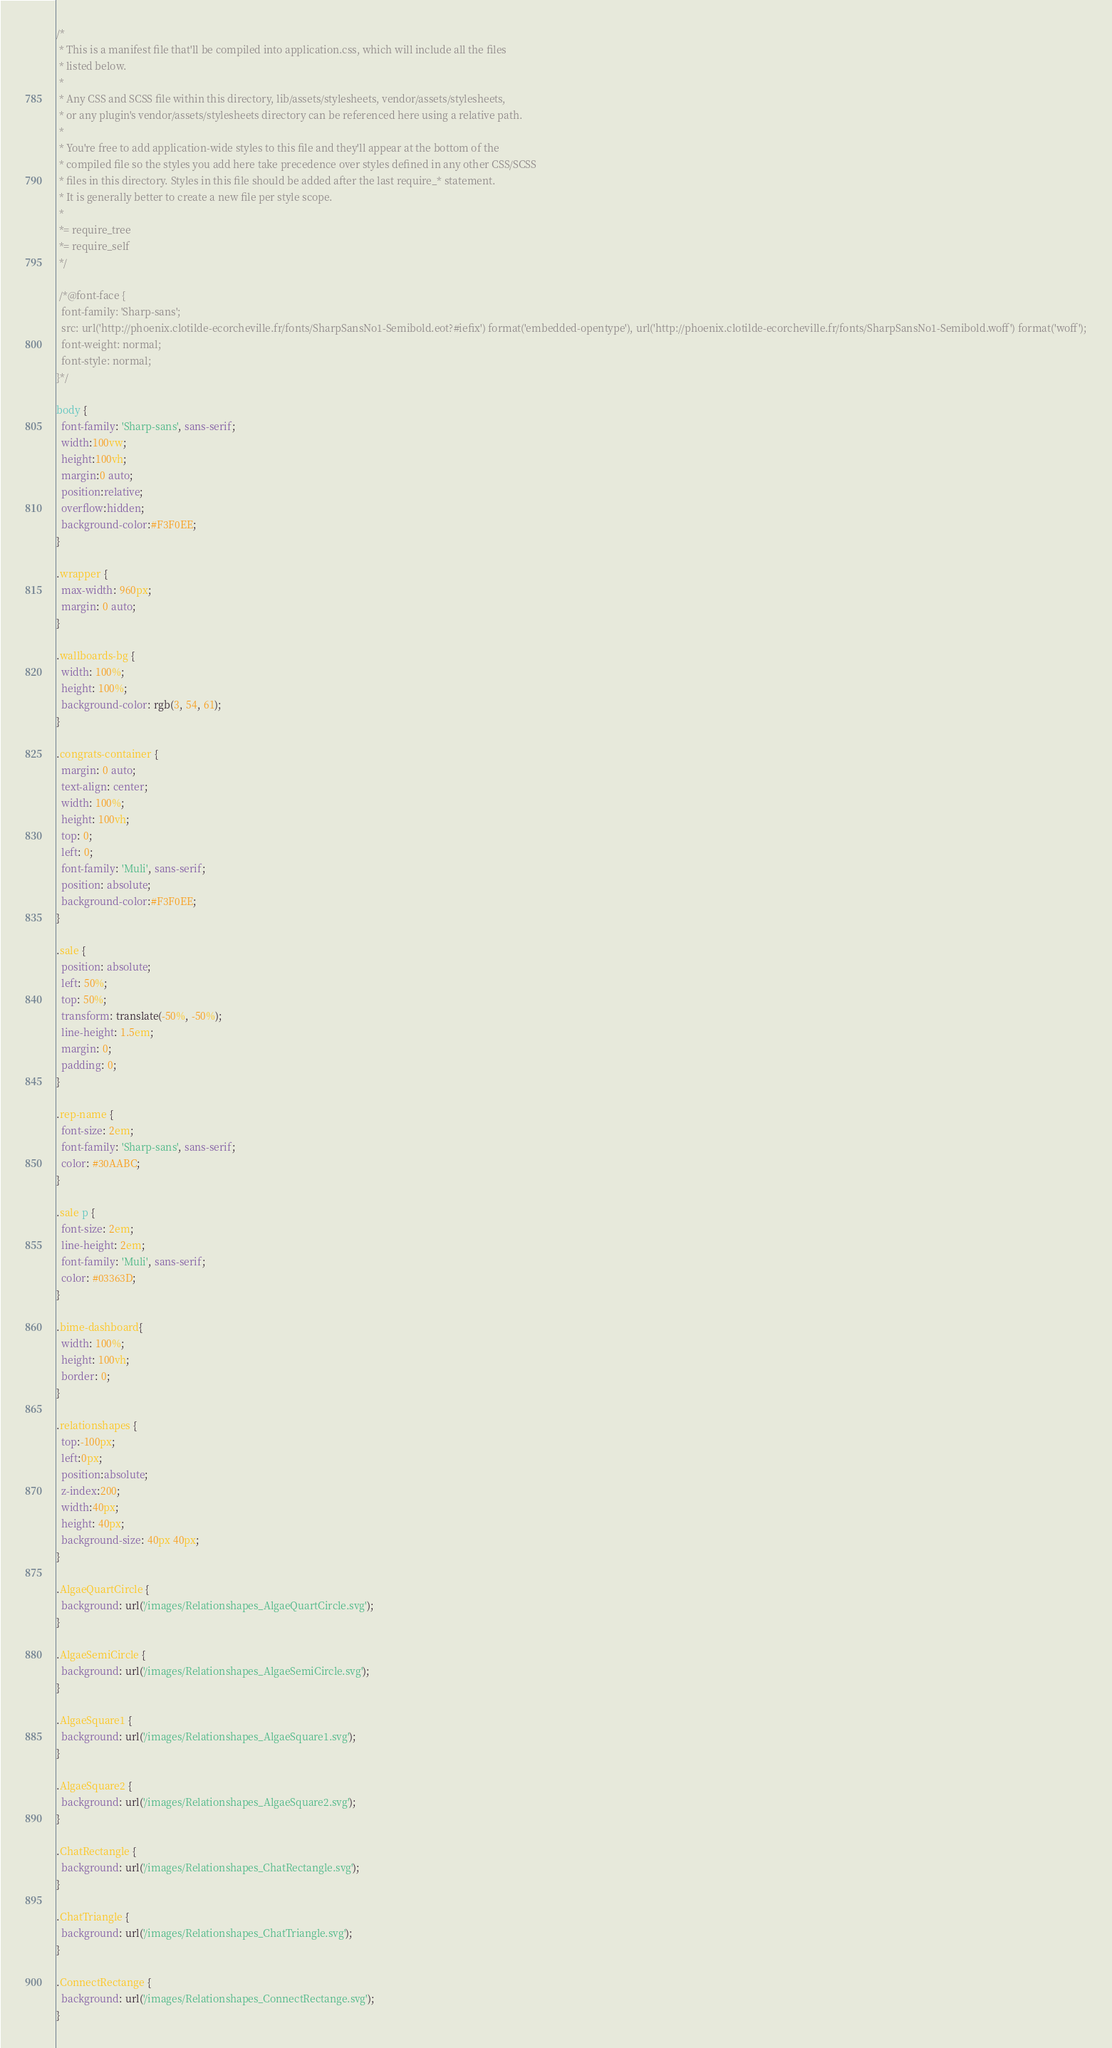<code> <loc_0><loc_0><loc_500><loc_500><_CSS_>/*
 * This is a manifest file that'll be compiled into application.css, which will include all the files
 * listed below.
 *
 * Any CSS and SCSS file within this directory, lib/assets/stylesheets, vendor/assets/stylesheets,
 * or any plugin's vendor/assets/stylesheets directory can be referenced here using a relative path.
 *
 * You're free to add application-wide styles to this file and they'll appear at the bottom of the
 * compiled file so the styles you add here take precedence over styles defined in any other CSS/SCSS
 * files in this directory. Styles in this file should be added after the last require_* statement.
 * It is generally better to create a new file per style scope.
 *
 *= require_tree
 *= require_self
 */

 /*@font-face {
  font-family: 'Sharp-sans';
  src: url('http://phoenix.clotilde-ecorcheville.fr/fonts/SharpSansNo1-Semibold.eot?#iefix') format('embedded-opentype'), url('http://phoenix.clotilde-ecorcheville.fr/fonts/SharpSansNo1-Semibold.woff') format('woff');
  font-weight: normal;
  font-style: normal;
}*/

body {
  font-family: 'Sharp-sans', sans-serif;
  width:100vw;
  height:100vh;
  margin:0 auto;
  position:relative;
  overflow:hidden;
  background-color:#F3F0EE;
}

.wrapper {
  max-width: 960px;
  margin: 0 auto;
}

.wallboards-bg {
  width: 100%;
  height: 100%;
  background-color: rgb(3, 54, 61);
}

.congrats-container {
  margin: 0 auto;
  text-align: center;
  width: 100%;
  height: 100vh;
  top: 0;
  left: 0;
  font-family: 'Muli', sans-serif;
  position: absolute;
  background-color:#F3F0EE;
}

.sale {
  position: absolute;
  left: 50%;
  top: 50%;
  transform: translate(-50%, -50%);
  line-height: 1.5em;
  margin: 0;
  padding: 0;
}

.rep-name {
  font-size: 2em;
  font-family: 'Sharp-sans', sans-serif;
  color: #30AABC;
}

.sale p {
  font-size: 2em;
  line-height: 2em;
  font-family: 'Muli', sans-serif;
  color: #03363D;
}

.bime-dashboard{
  width: 100%;
  height: 100vh;
  border: 0;
}

.relationshapes {
  top:-100px;
  left:0px;
  position:absolute;
  z-index:200;
  width:40px;
  height: 40px;
  background-size: 40px 40px;
}

.AlgaeQuartCircle {
  background: url('/images/Relationshapes_AlgaeQuartCircle.svg');
}

.AlgaeSemiCircle {
  background: url('/images/Relationshapes_AlgaeSemiCircle.svg');
}

.AlgaeSquare1 {
  background: url('/images/Relationshapes_AlgaeSquare1.svg');
}

.AlgaeSquare2 {
  background: url('/images/Relationshapes_AlgaeSquare2.svg');
}

.ChatRectangle {
  background: url('/images/Relationshapes_ChatRectangle.svg');
}

.ChatTriangle {
  background: url('/images/Relationshapes_ChatTriangle.svg');
}

.ConnectRectange {
  background: url('/images/Relationshapes_ConnectRectange.svg');
}
</code> 